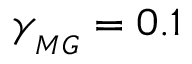<formula> <loc_0><loc_0><loc_500><loc_500>\gamma _ { _ { M G } } = 0 . 1</formula> 